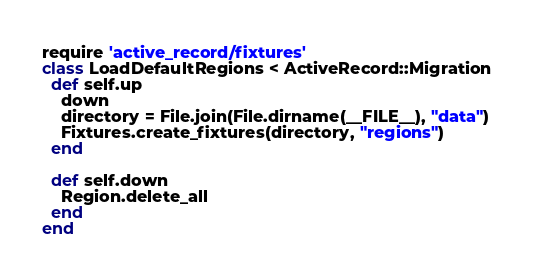<code> <loc_0><loc_0><loc_500><loc_500><_Ruby_>require 'active_record/fixtures'
class LoadDefaultRegions < ActiveRecord::Migration
  def self.up
    down
    directory = File.join(File.dirname(__FILE__), "data")
    Fixtures.create_fixtures(directory, "regions")
  end

  def self.down
    Region.delete_all
  end
end
</code> 